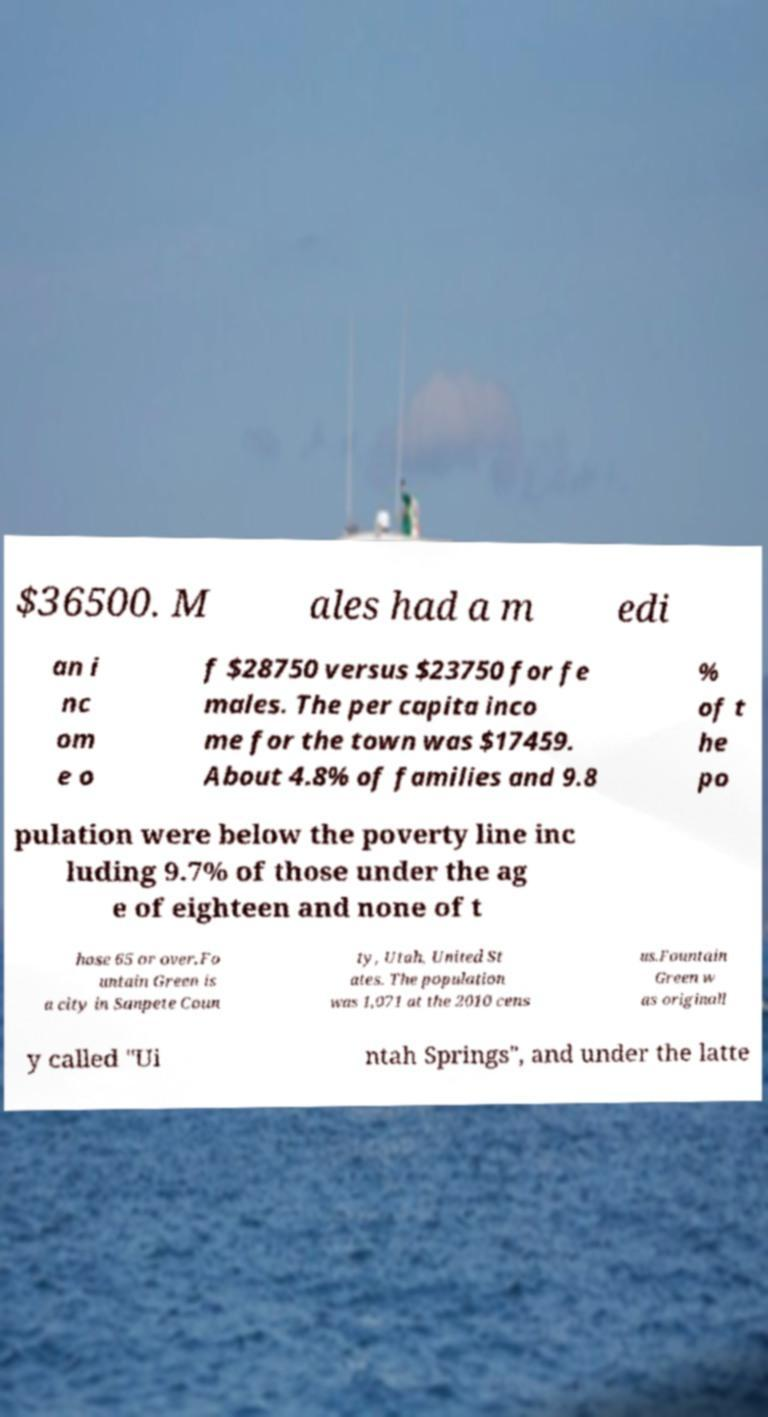Can you accurately transcribe the text from the provided image for me? $36500. M ales had a m edi an i nc om e o f $28750 versus $23750 for fe males. The per capita inco me for the town was $17459. About 4.8% of families and 9.8 % of t he po pulation were below the poverty line inc luding 9.7% of those under the ag e of eighteen and none of t hose 65 or over.Fo untain Green is a city in Sanpete Coun ty, Utah, United St ates. The population was 1,071 at the 2010 cens us.Fountain Green w as originall y called "Ui ntah Springs", and under the latte 